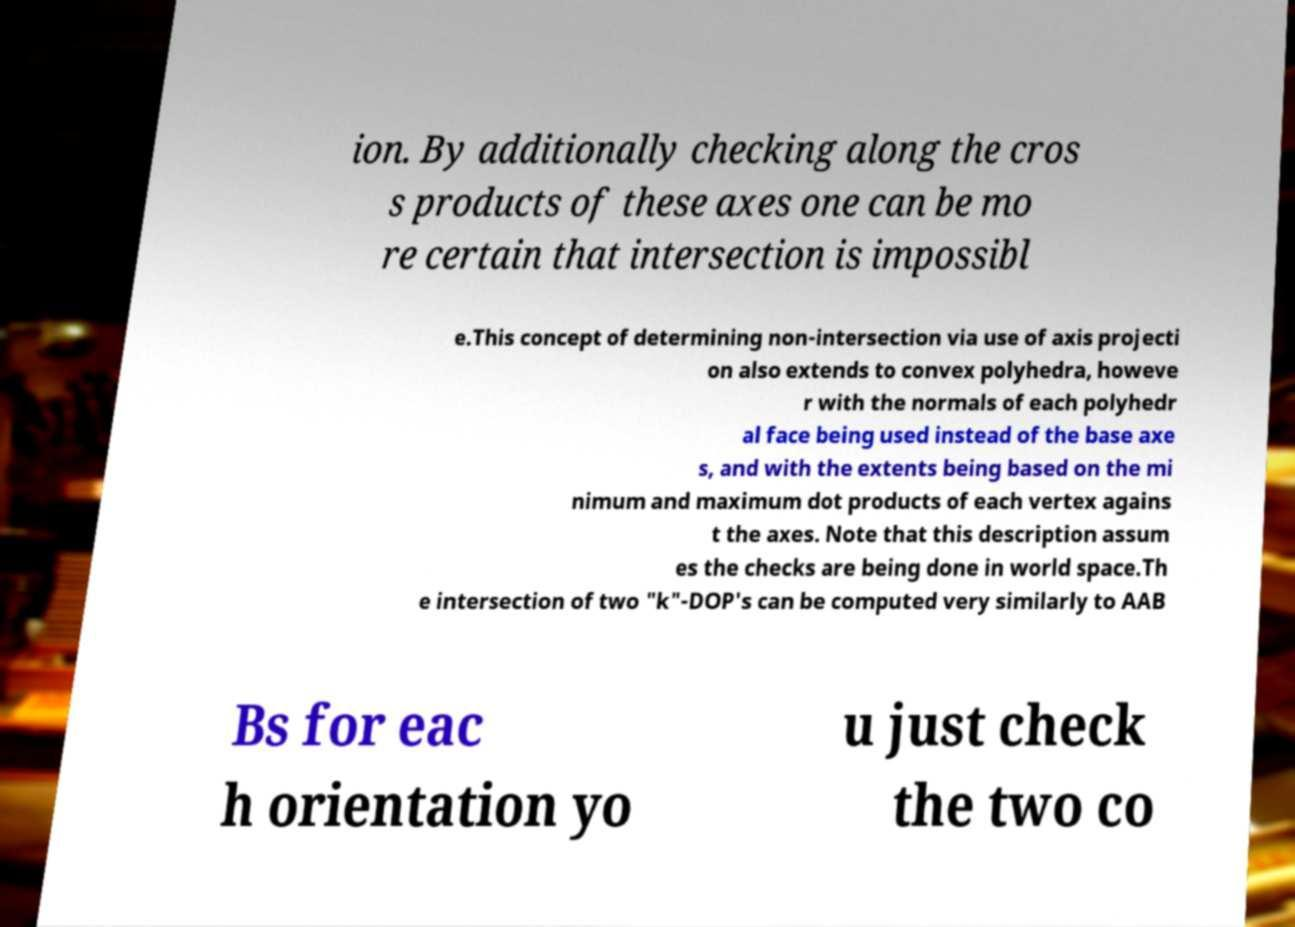Please read and relay the text visible in this image. What does it say? ion. By additionally checking along the cros s products of these axes one can be mo re certain that intersection is impossibl e.This concept of determining non-intersection via use of axis projecti on also extends to convex polyhedra, howeve r with the normals of each polyhedr al face being used instead of the base axe s, and with the extents being based on the mi nimum and maximum dot products of each vertex agains t the axes. Note that this description assum es the checks are being done in world space.Th e intersection of two "k"-DOP's can be computed very similarly to AAB Bs for eac h orientation yo u just check the two co 